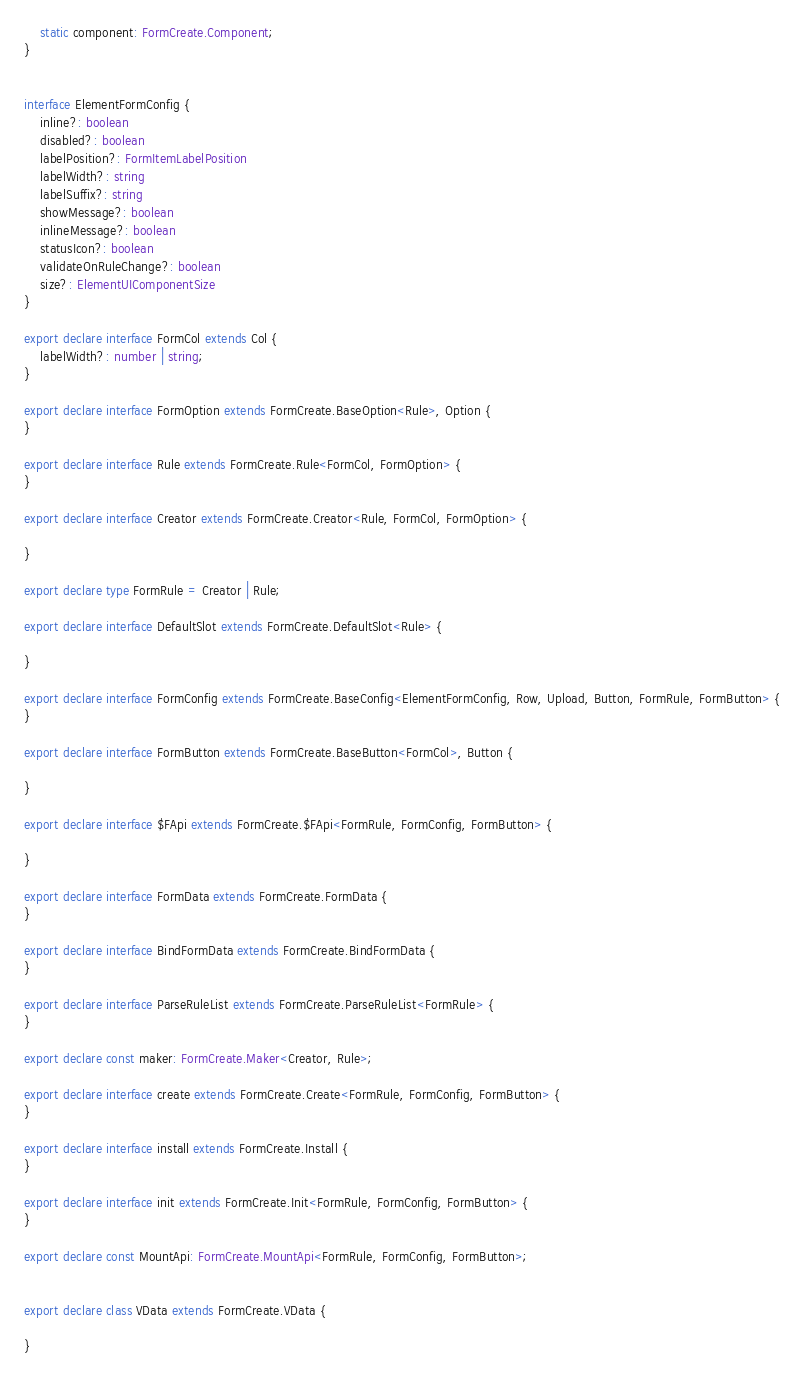Convert code to text. <code><loc_0><loc_0><loc_500><loc_500><_TypeScript_>    static component: FormCreate.Component;
}


interface ElementFormConfig {
    inline?: boolean
    disabled?: boolean
    labelPosition?: FormItemLabelPosition
    labelWidth?: string
    labelSuffix?: string
    showMessage?: boolean
    inlineMessage?: boolean
    statusIcon?: boolean
    validateOnRuleChange?: boolean
    size?: ElementUIComponentSize
}

export declare interface FormCol extends Col {
    labelWidth?: number | string;
}

export declare interface FormOption extends FormCreate.BaseOption<Rule>, Option {
}

export declare interface Rule extends FormCreate.Rule<FormCol, FormOption> {
}

export declare interface Creator extends FormCreate.Creator<Rule, FormCol, FormOption> {

}

export declare type FormRule = Creator | Rule;

export declare interface DefaultSlot extends FormCreate.DefaultSlot<Rule> {

}

export declare interface FormConfig extends FormCreate.BaseConfig<ElementFormConfig, Row, Upload, Button, FormRule, FormButton> {
}

export declare interface FormButton extends FormCreate.BaseButton<FormCol>, Button {

}

export declare interface $FApi extends FormCreate.$FApi<FormRule, FormConfig, FormButton> {

}

export declare interface FormData extends FormCreate.FormData {
}

export declare interface BindFormData extends FormCreate.BindFormData {
}

export declare interface ParseRuleList extends FormCreate.ParseRuleList<FormRule> {
}

export declare const maker: FormCreate.Maker<Creator, Rule>;

export declare interface create extends FormCreate.Create<FormRule, FormConfig, FormButton> {
}

export declare interface install extends FormCreate.Install {
}

export declare interface init extends FormCreate.Init<FormRule, FormConfig, FormButton> {
}

export declare const MountApi: FormCreate.MountApi<FormRule, FormConfig, FormButton>;


export declare class VData extends FormCreate.VData {

}
</code> 